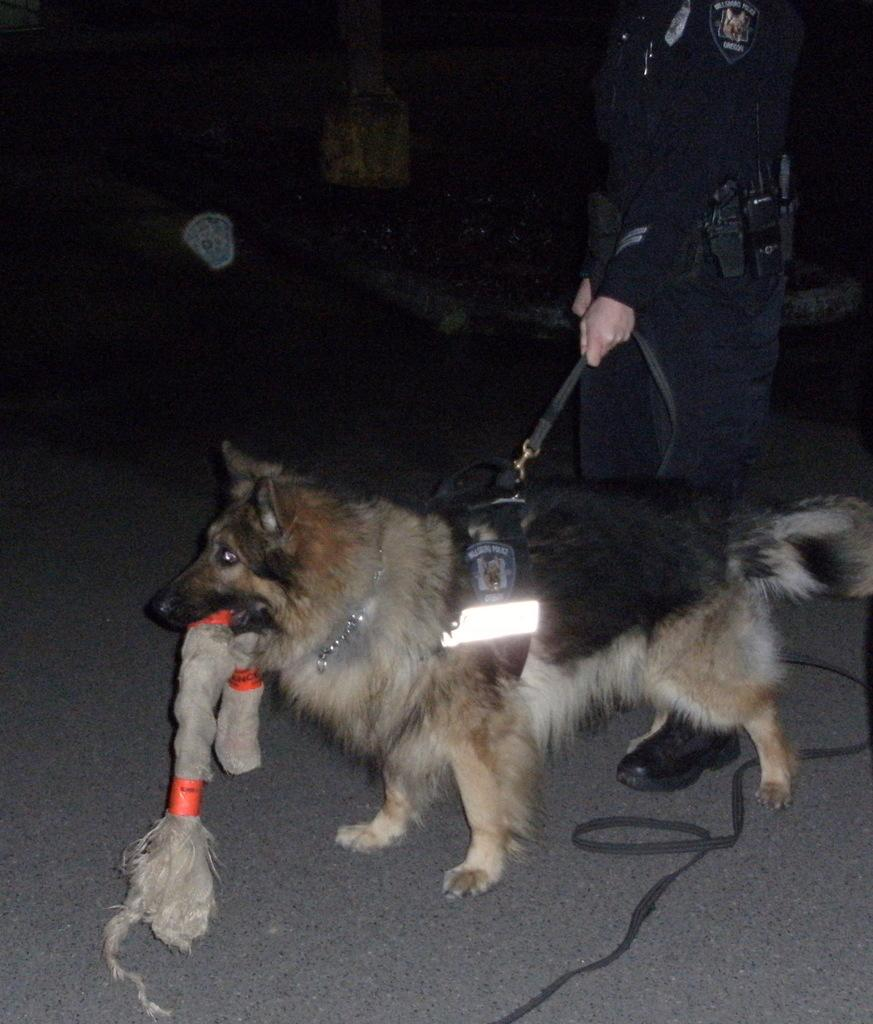What animal is on the road in the image? There is a dog on the road in the image. What can be seen in the image that might be used for illumination? There is a light visible in the image. Who is holding the light in the image? There is a person holding the light in the image. What type of chin can be seen on the dog in the image? There is no chin visible on the dog in the image, as it is a two-dimensional representation. What answer is the dog giving in the image? The dog is not giving any answer in the image, as it is a non-verbal animal. 